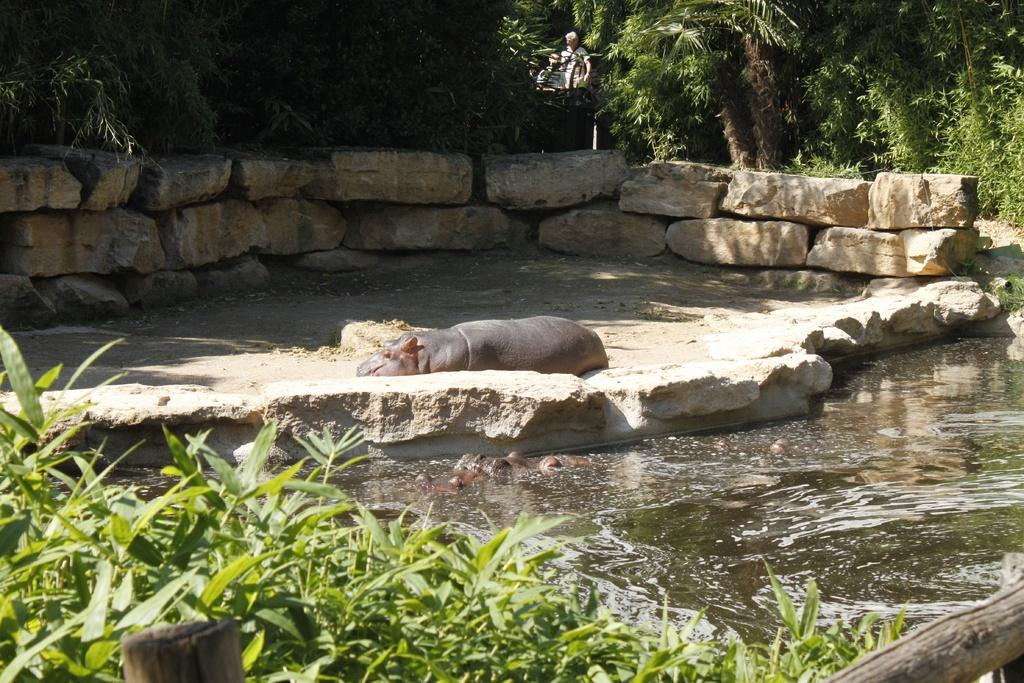What type of animal is in the image? There is an animal in the image, but we cannot determine its exact species without more information. What is the primary element visible in the image? Water is visible in the image. What type of vegetation can be seen in the image? There are trees in the image. How does the boy start the kite in the image? There is no boy or kite present in the image. 